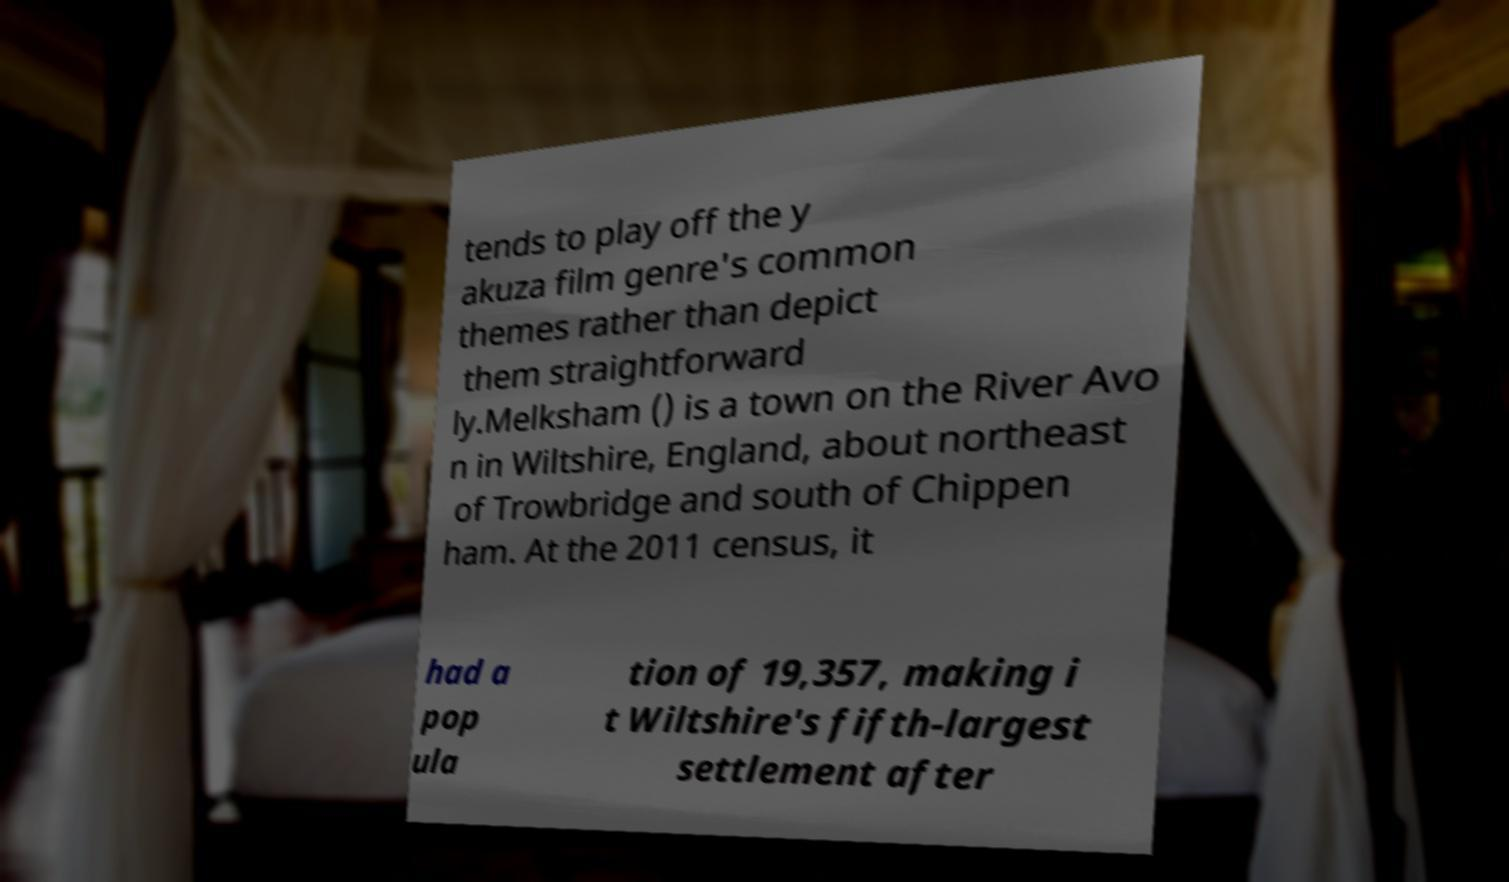What messages or text are displayed in this image? I need them in a readable, typed format. tends to play off the y akuza film genre's common themes rather than depict them straightforward ly.Melksham () is a town on the River Avo n in Wiltshire, England, about northeast of Trowbridge and south of Chippen ham. At the 2011 census, it had a pop ula tion of 19,357, making i t Wiltshire's fifth-largest settlement after 